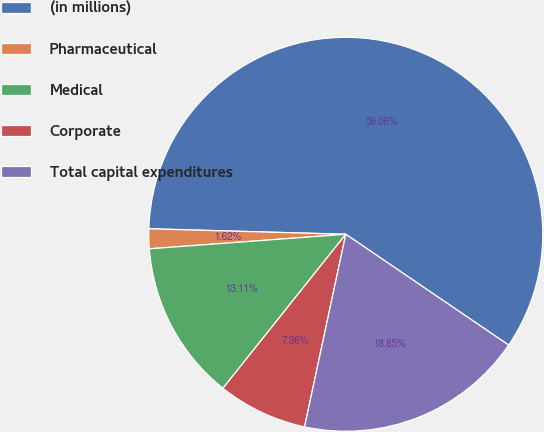<chart> <loc_0><loc_0><loc_500><loc_500><pie_chart><fcel>(in millions)<fcel>Pharmaceutical<fcel>Medical<fcel>Corporate<fcel>Total capital expenditures<nl><fcel>59.07%<fcel>1.62%<fcel>13.11%<fcel>7.36%<fcel>18.85%<nl></chart> 